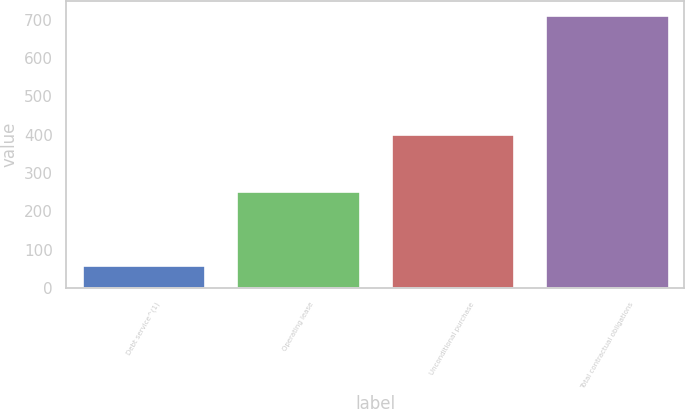<chart> <loc_0><loc_0><loc_500><loc_500><bar_chart><fcel>Debt service^(1)<fcel>Operating lease<fcel>Unconditional purchase<fcel>Total contractual obligations<nl><fcel>59.4<fcel>252.5<fcel>401.5<fcel>713.4<nl></chart> 